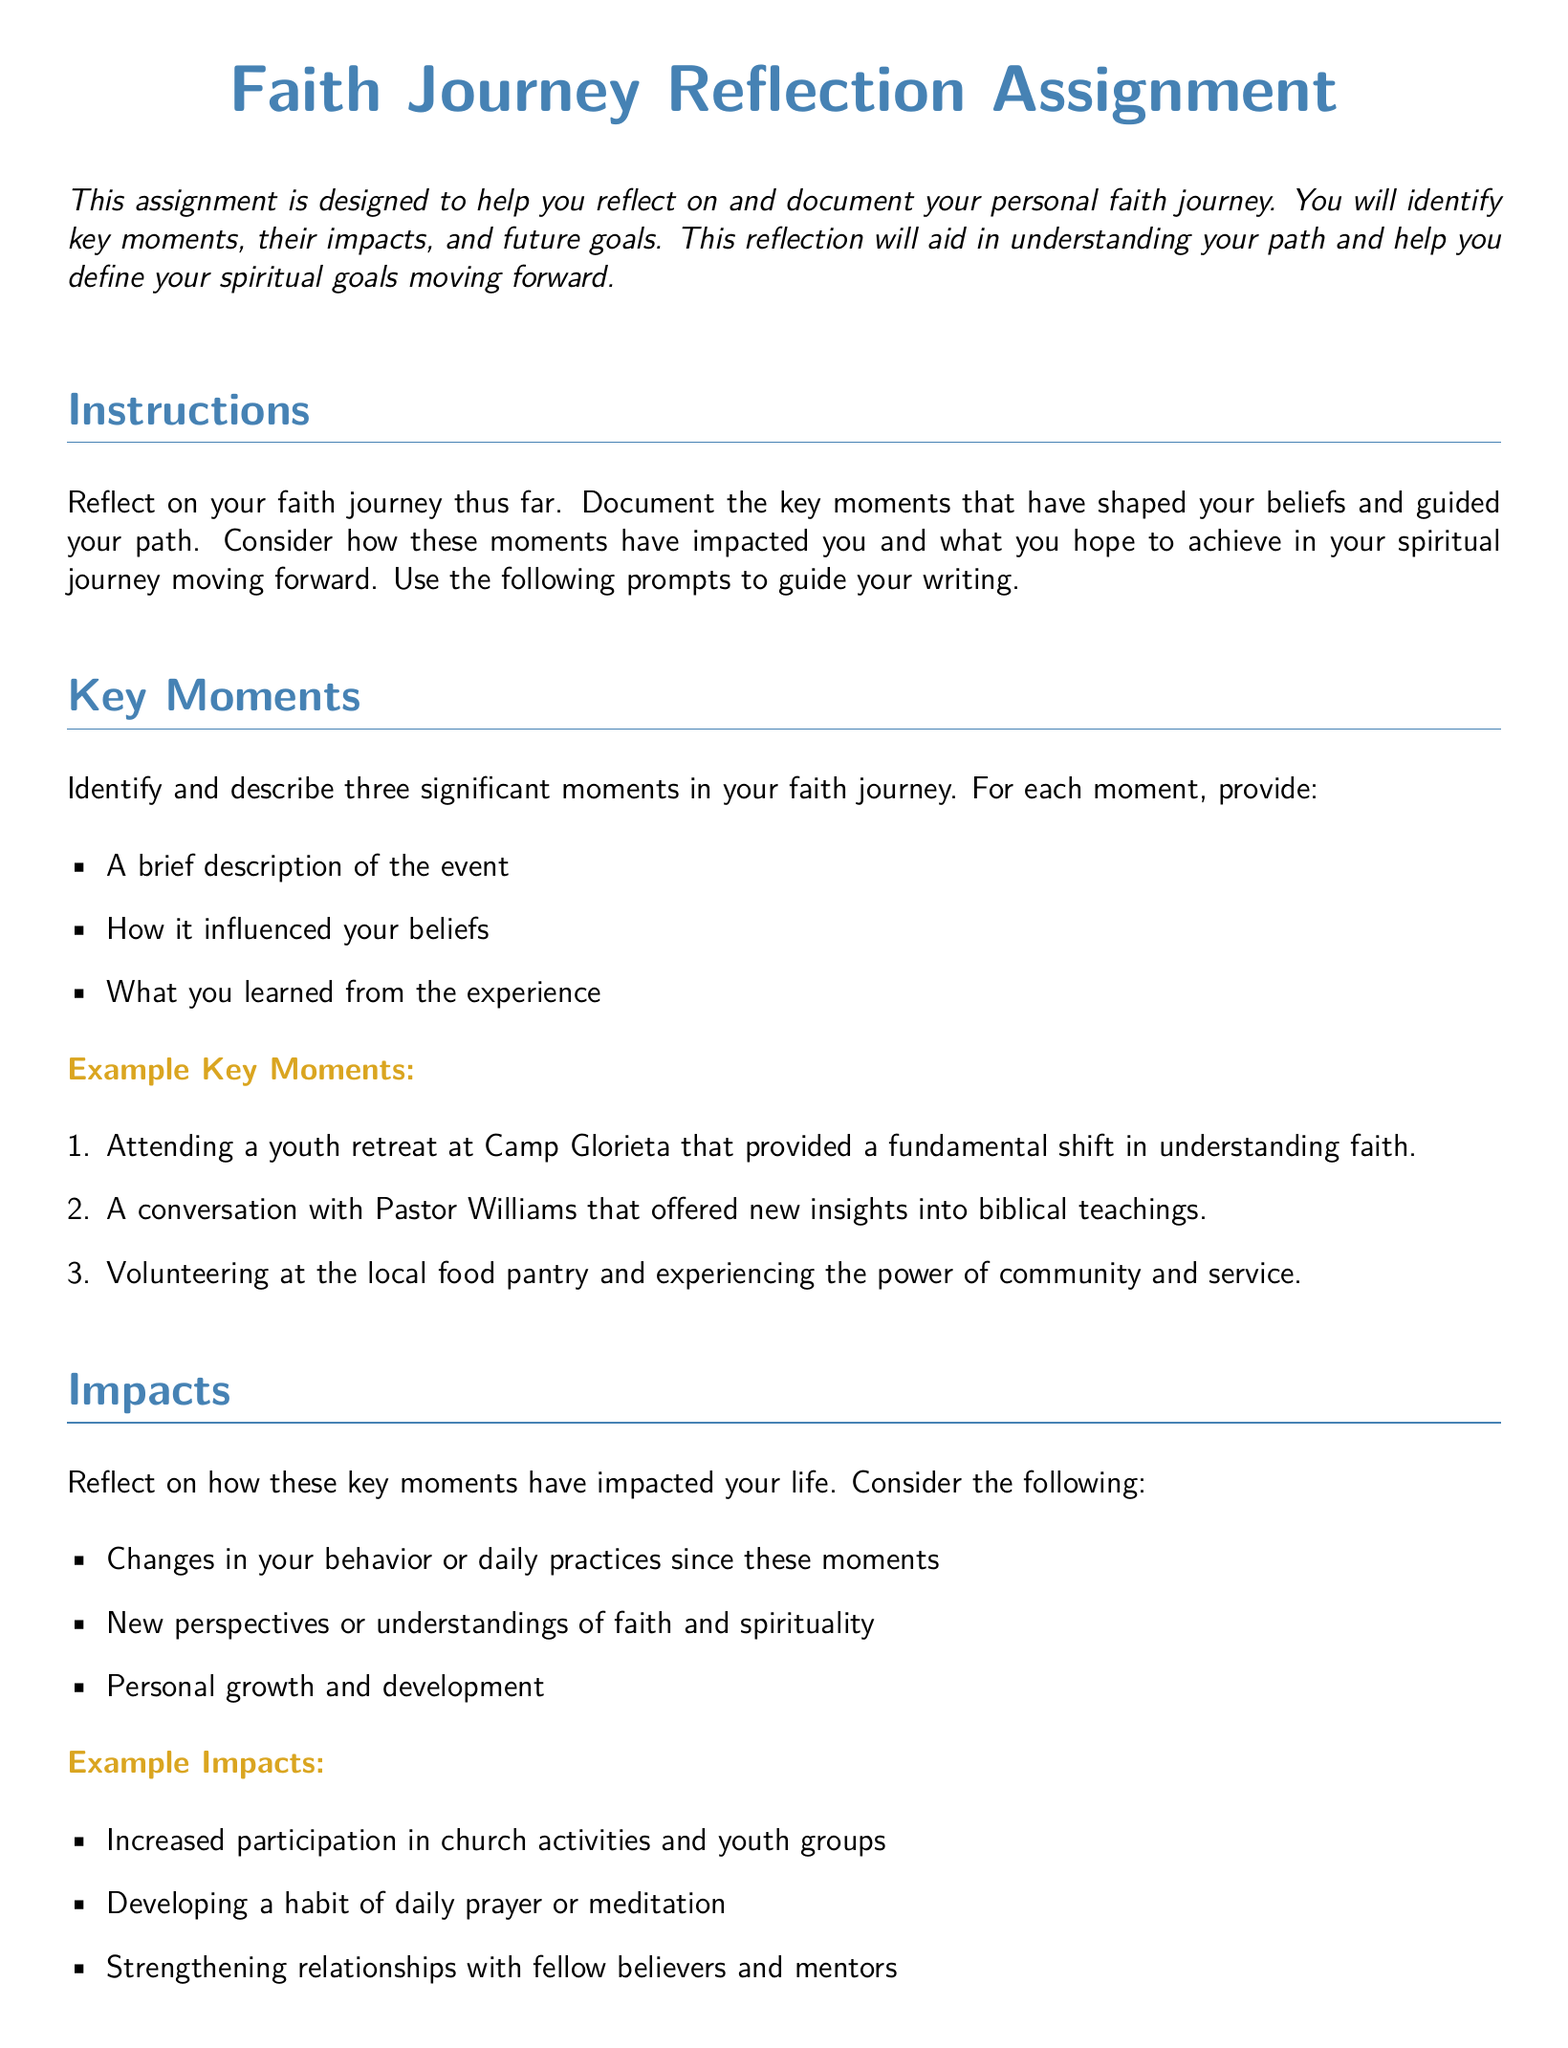What is the title of the assignment? The title of the assignment is explicitly stated in the document as "Faith Journey Reflection Assignment."
Answer: Faith Journey Reflection Assignment How many significant moments should students identify? The document specifies that students should identify three significant moments in their faith journey.
Answer: Three What color is used for the title of the assignment? The document indicates that the title of the assignment is colored with a specific RGB value, which is described as faith blue.
Answer: Faith blue What is the main purpose of the assignment? The main purpose of the assignment is to help students reflect on and document their personal faith journey.
Answer: Reflect on and document personal faith journey Name one of the example impacts listed in the document. One of the example impacts listed is "Increased participation in church activities and youth groups."
Answer: Increased participation in church activities and youth groups What is the length requirement for the essay? The assignment specifies that the essay should be one page long.
Answer: One page What future goal involves attending a Bible study group? The future goal that involves attending a Bible study group is committing to attend a weekly Bible study group.
Answer: Committing to attend a weekly Bible study group What type of submission is required for this assignment? The document states that a one-page essay summarizing the reflection is required for submission.
Answer: One-page essay Which section discusses personal growth and development? The "Impacts" section reflects on personal growth and development.
Answer: Impacts 